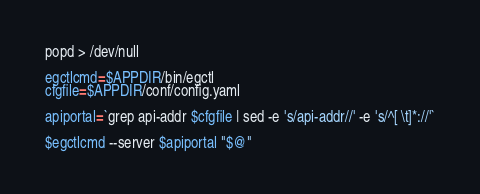<code> <loc_0><loc_0><loc_500><loc_500><_Bash_>popd > /dev/null

egctlcmd=$APPDIR/bin/egctl
cfgfile=$APPDIR/conf/config.yaml

apiportal=`grep api-addr $cfgfile | sed -e 's/api-addr//' -e 's/^[ \t]*://'`

$egctlcmd --server $apiportal "$@"



</code> 